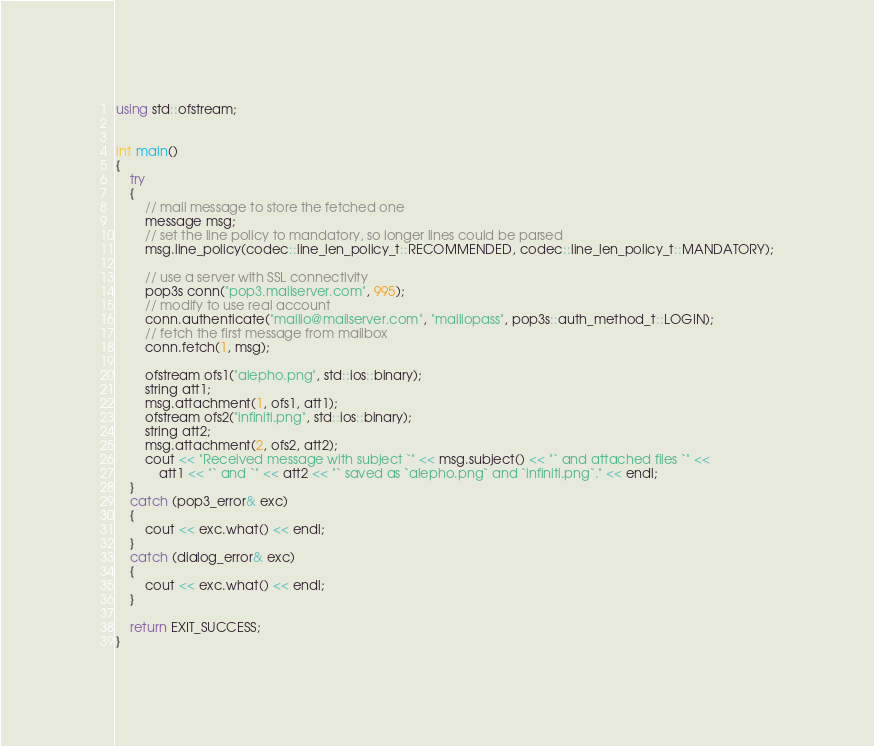<code> <loc_0><loc_0><loc_500><loc_500><_C++_>using std::ofstream;


int main()
{
    try
    {
        // mail message to store the fetched one
        message msg;
        // set the line policy to mandatory, so longer lines could be parsed
        msg.line_policy(codec::line_len_policy_t::RECOMMENDED, codec::line_len_policy_t::MANDATORY);

        // use a server with SSL connectivity
        pop3s conn("pop3.mailserver.com", 995);
        // modify to use real account
        conn.authenticate("mailio@mailserver.com", "mailiopass", pop3s::auth_method_t::LOGIN);
        // fetch the first message from mailbox
        conn.fetch(1, msg);
        
        ofstream ofs1("alepho.png", std::ios::binary);
        string att1;
        msg.attachment(1, ofs1, att1);
        ofstream ofs2("infiniti.png", std::ios::binary);
        string att2;
        msg.attachment(2, ofs2, att2);
        cout << "Received message with subject `" << msg.subject() << "` and attached files `" <<
            att1 << "` and `" << att2 << "` saved as `alepho.png` and `infiniti.png`." << endl;
    }
    catch (pop3_error& exc)
    {
        cout << exc.what() << endl;
    }
    catch (dialog_error& exc)
    {
        cout << exc.what() << endl;
    }

    return EXIT_SUCCESS;
}
</code> 